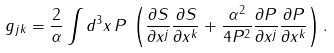Convert formula to latex. <formula><loc_0><loc_0><loc_500><loc_500>g _ { j k } = \frac { 2 } { \alpha } \int d ^ { 3 } x \, P \, \left ( \frac { \partial S } { \partial x ^ { j } } \frac { \partial S } { \partial x ^ { k } } + \frac { \alpha ^ { 2 } } { 4 P ^ { 2 } } \frac { \partial P } { \partial x ^ { j } } \frac { \partial P } { \partial x ^ { k } } \right ) .</formula> 